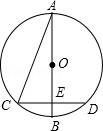Consider the given diagram, where AB represents the diameter of circle O and CD is a chord perpendicular to AB. Let E be the foot of the perpendicular from C to AB, and AC be the segment connecting points A and C. If the measure of angle CAB is 22.5 degrees and CD measures 8.0 cm, what is the value of the radius of circle O, expressed as variable 'r' in relation to the given variables? To find the radius 'r' of circle O, begin by noting that AB is the diameter and thus the longest distance across the circle. When CD, a perpendicular chord, bisects AB at point E, it splits CD equally into two 4 cm segments, making CE and DE each 4 cm. Observing that triangle AOC must be isosceles (as OA and OC are radii of the circle), and given that angle CAB is 22.5 degrees, triangle OCE forms a 45-degree angle (double of 22.5 degrees) at E due to its isosceles nature. This unique feature establishes triangle OCE as an isosceles right triangle. With CE being 4 cm, OC (the hypotenuse) follows as 4√2 cm because in such triangles, the hypotenuse equals one leg times √2. Thus, the radius r of circle O is effectively 4√2 cm, aligning with option C. 